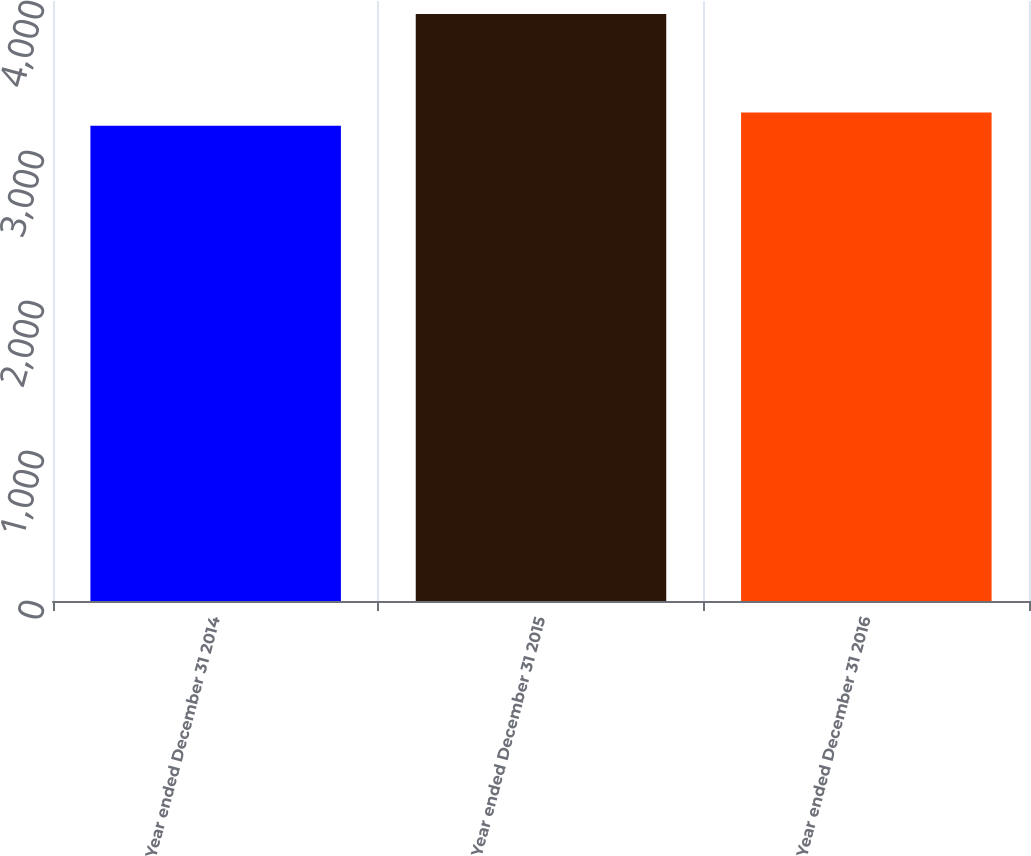<chart> <loc_0><loc_0><loc_500><loc_500><bar_chart><fcel>Year ended December 31 2014<fcel>Year ended December 31 2015<fcel>Year ended December 31 2016<nl><fcel>3169<fcel>3913<fcel>3257<nl></chart> 